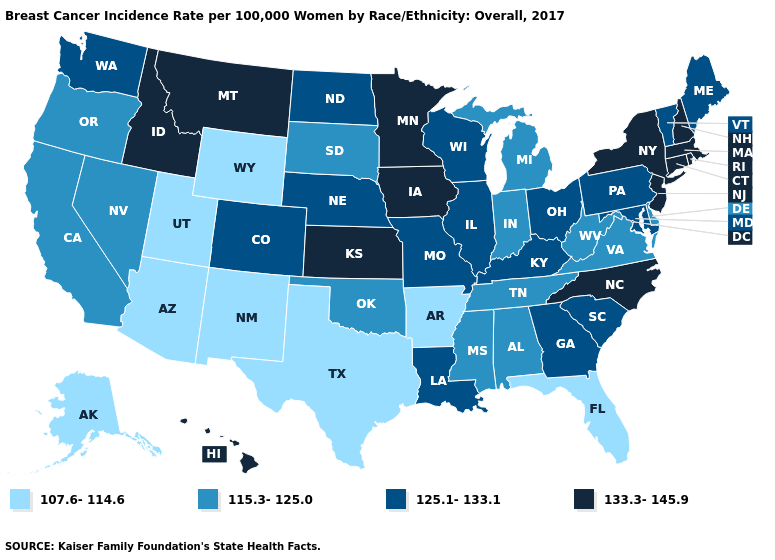Does Massachusetts have the lowest value in the Northeast?
Be succinct. No. Does the map have missing data?
Be succinct. No. Among the states that border Virginia , does Tennessee have the highest value?
Short answer required. No. What is the lowest value in the USA?
Write a very short answer. 107.6-114.6. Does Alabama have the lowest value in the South?
Write a very short answer. No. Does the first symbol in the legend represent the smallest category?
Write a very short answer. Yes. Name the states that have a value in the range 107.6-114.6?
Concise answer only. Alaska, Arizona, Arkansas, Florida, New Mexico, Texas, Utah, Wyoming. Which states have the lowest value in the USA?
Write a very short answer. Alaska, Arizona, Arkansas, Florida, New Mexico, Texas, Utah, Wyoming. Which states have the lowest value in the USA?
Write a very short answer. Alaska, Arizona, Arkansas, Florida, New Mexico, Texas, Utah, Wyoming. What is the lowest value in the Northeast?
Answer briefly. 125.1-133.1. Which states have the highest value in the USA?
Give a very brief answer. Connecticut, Hawaii, Idaho, Iowa, Kansas, Massachusetts, Minnesota, Montana, New Hampshire, New Jersey, New York, North Carolina, Rhode Island. Does Montana have the highest value in the USA?
Give a very brief answer. Yes. How many symbols are there in the legend?
Write a very short answer. 4. What is the value of Wisconsin?
Short answer required. 125.1-133.1. What is the lowest value in the West?
Short answer required. 107.6-114.6. 